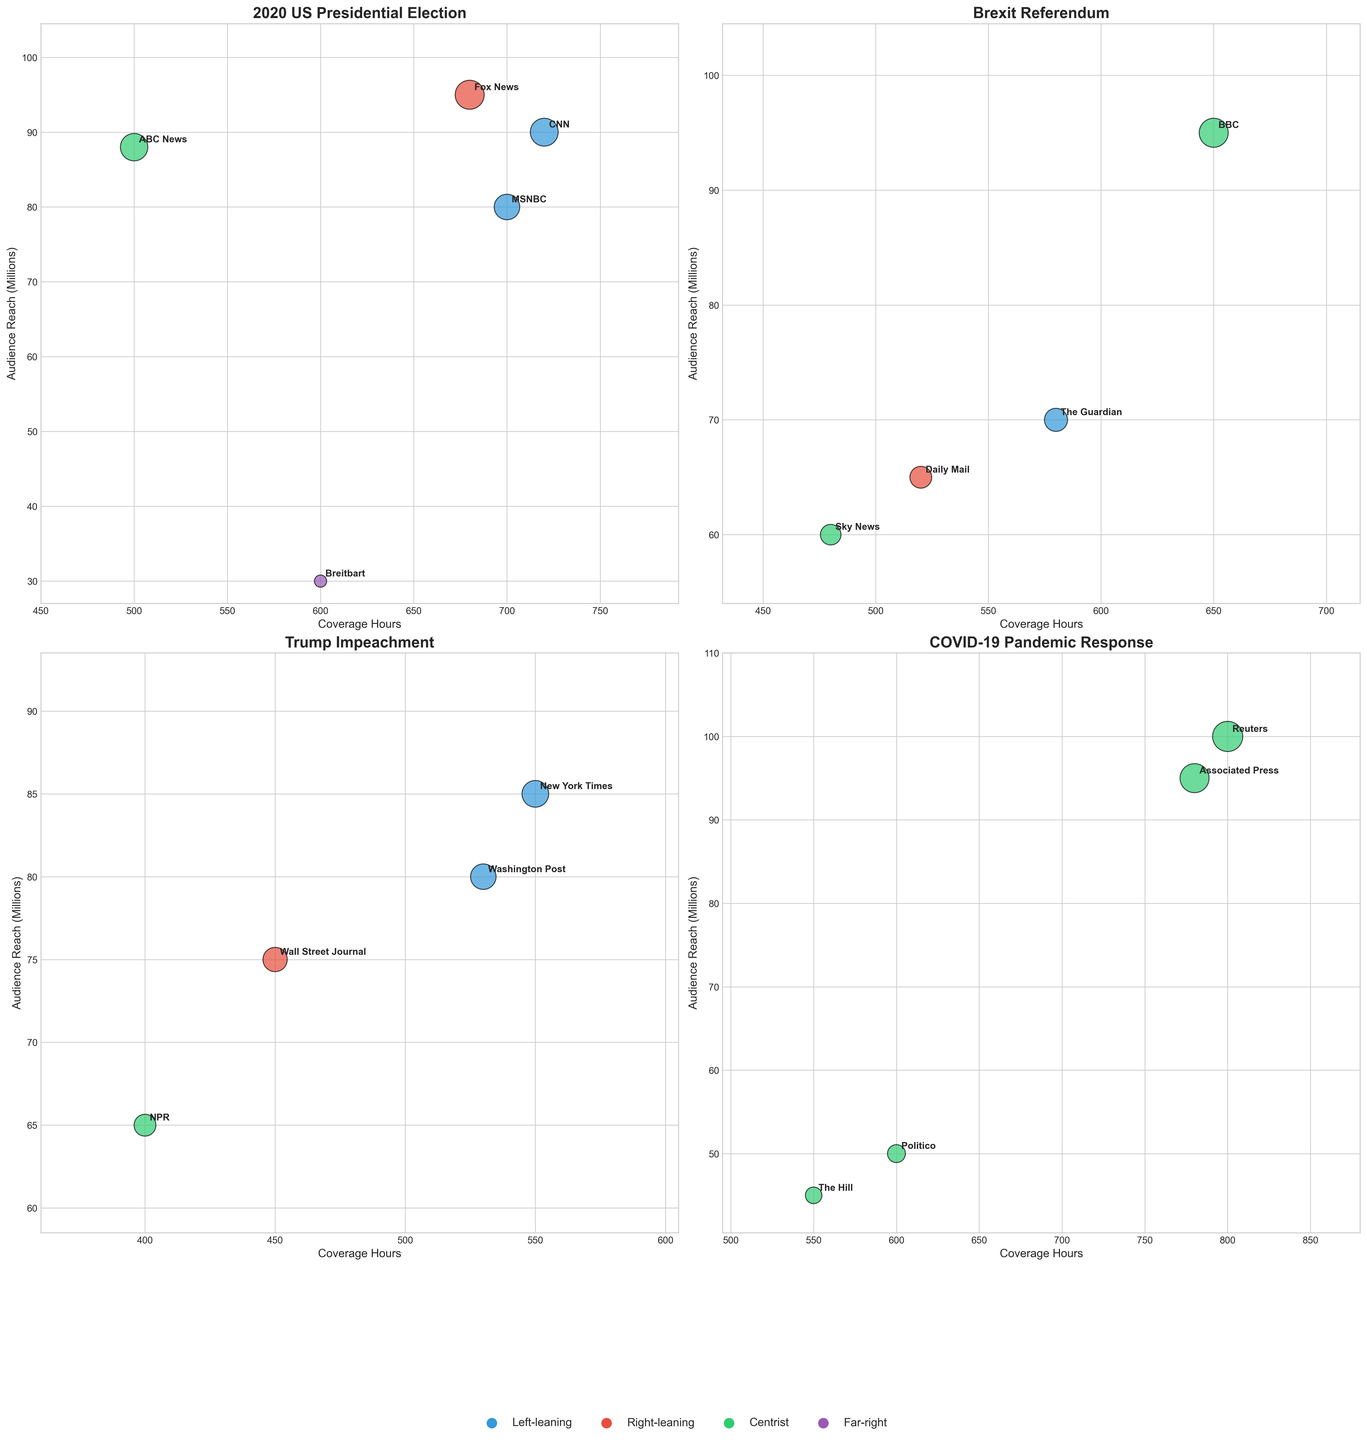What event had the highest total audience reach? By observing all the scatter plots, we can identify the event with the highest individual audience reach. The COVID-19 Pandemic Response event includes Reuters with an audience reach of 100 million, which is the highest among all events.
Answer: COVID-19 Pandemic Response Which news outlet covered the 2020 US Presidential Election for the longest duration? Referring to the subplot for the 2020 US Presidential Election, CNN had 720 coverage hours, which is the longest duration among all news outlets covering this event.
Answer: CNN Compare left-leaning and right-leaning coverage hours for the Brexit Referendum. Which had more? For the Brexit Referendum, The Guardian (left-leaning) had 580 coverage hours, while Daily Mail (right-leaning) had 520 coverage hours. Therefore, left-leaning outlets covered more hours.
Answer: Left-leaning How many centrist news outlets covered the Trump Impeachment? By looking at the subplot for Trump Impeachment, NPR is the only centrist news outlet covering this event.
Answer: 1 What is the total coverage hours for centrist outlets covering the COVID-19 Pandemic Response? Summing up the coverage hours for Reuters (800), Associated Press (780), Politico (600), and The Hill (550) under the COVID-19 Pandemic Response subplot, the total is 800 + 780 + 600 + 550 = 2730 hours.
Answer: 2730 Which event has the widest audience reach range from lowest to highest? By observing the subplots, we can see the range of audience reach varies greatly for the COVID-19 Pandemic Response—from 45 million (The Hill) to 100 million (Reuters). This is the widest range.
Answer: COVID-19 Pandemic Response Which centrist news outlet has the lowest coverage hours for the entire dataset, and for which event? NPR, covering the Trump Impeachment event with 400 coverage hours, holds the lowest coverage hours among all centrist news outlets.
Answer: NPR, Trump Impeachment For the 2020 US Presidential Election, is there a correlation observed between audience reach and political leaning? For this event, the left-leaning outlets (CNN, MSNBC) have audience reaches of 90M and 80M, right-leaning (Fox News) has 95M, and the far-right (Breitbart) has 30M. Both centrist (ABC News) have 88M. No straightforward correlation is evident purely based on the subplot.
Answer: No clear correlation 